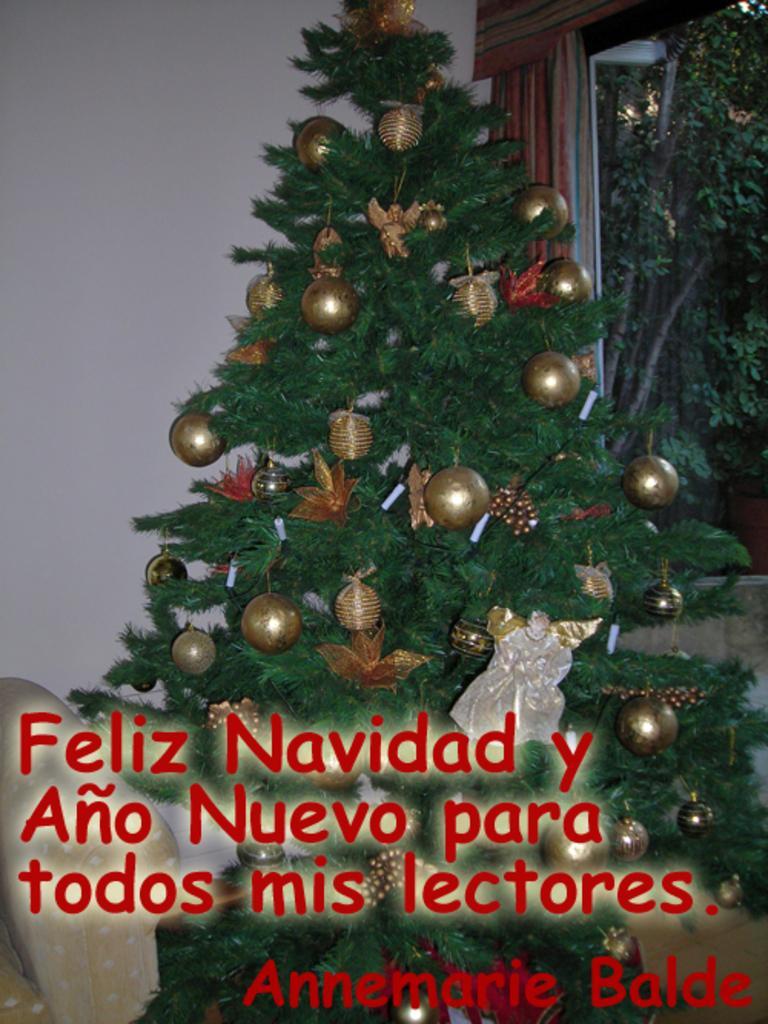Can you describe this image briefly? In this picture we can see an Christmas tree and some text, and we can find few decorative items, in the background we can see few trees. 